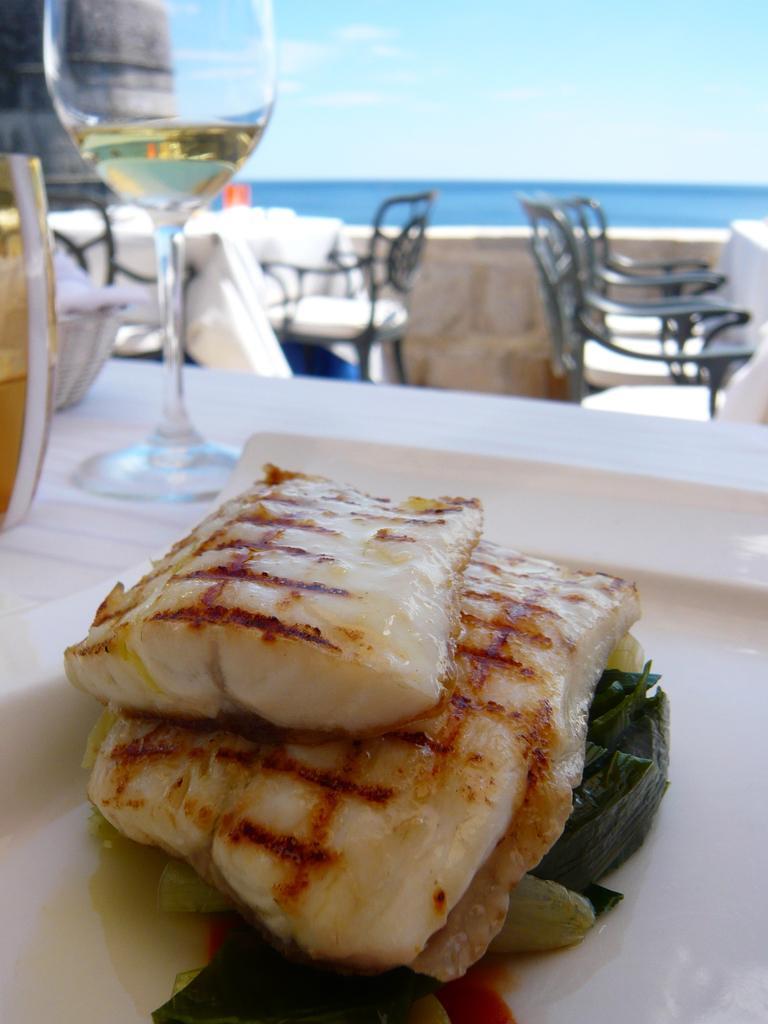In one or two sentences, can you explain what this image depicts? In this image i can see a food, glass, a bowl on a table at the background i can see chairs, benches, water and sky. 